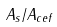Convert formula to latex. <formula><loc_0><loc_0><loc_500><loc_500>A _ { s } / A _ { c e f }</formula> 